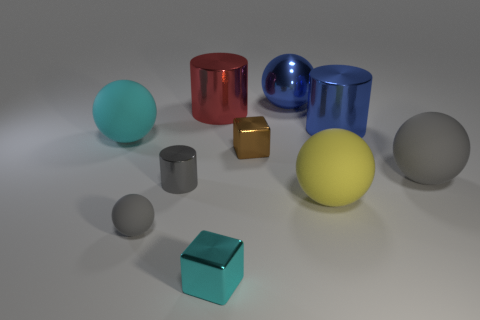How many large things are either brown metal blocks or spheres? 4 